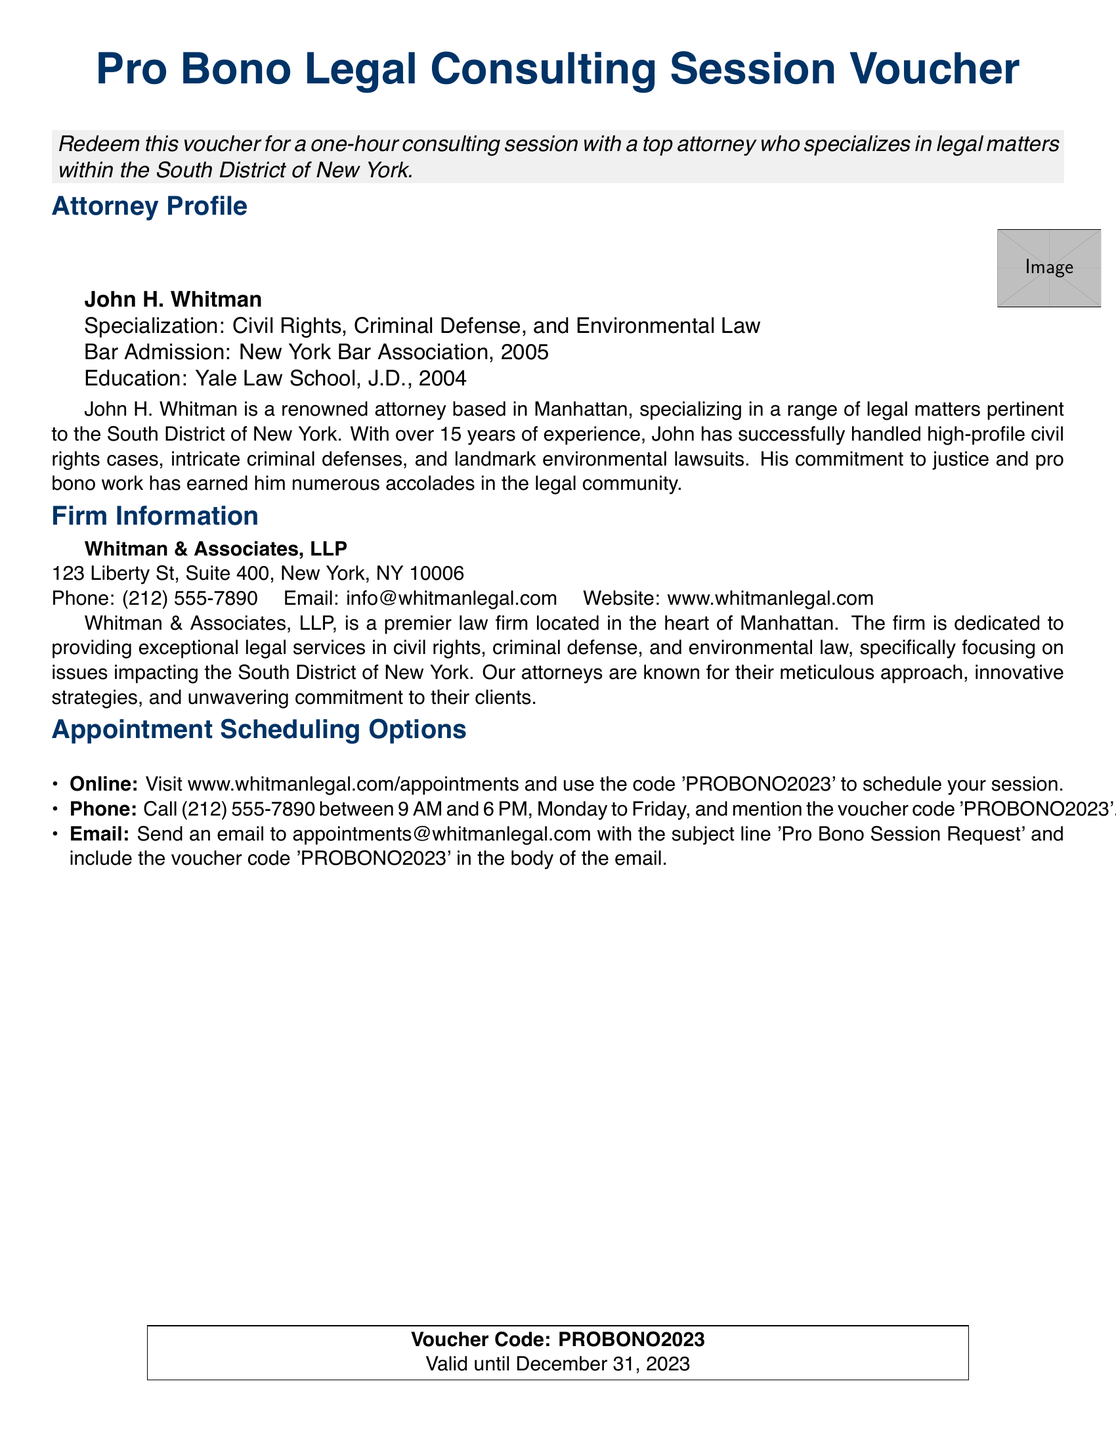What is the attorney's name? The attorney's name is listed in the "Attorney Profile" section of the document.
Answer: John H. Whitman What year was the attorney admitted to the New York Bar Association? The admission year is mentioned under the attorney's profile in the document.
Answer: 2005 What is the specialization of the attorney? The specialization is provided in the attorney's profile section.
Answer: Civil Rights, Criminal Defense, and Environmental Law What is the address of the law firm? The address can be found in the "Firm Information" section of the document.
Answer: 123 Liberty St, Suite 400, New York, NY 10006 What is the website for scheduling appointments? The website is specified in the appointment scheduling options section.
Answer: www.whitmanlegal.com/appointments How can you schedule an appointment by phone? The phone scheduling method is described in the "Appointment Scheduling Options."
Answer: Call (212) 555-7890 What is the voucher code? The voucher code is listed near the end of the document for redemption.
Answer: PROBONO2023 Until when is the voucher valid? The voucher's validity period is clearly stated in the document.
Answer: December 31, 2023 What firm is John H. Whitman associated with? The firm's name is provided in the "Firm Information" section.
Answer: Whitman & Associates, LLP 